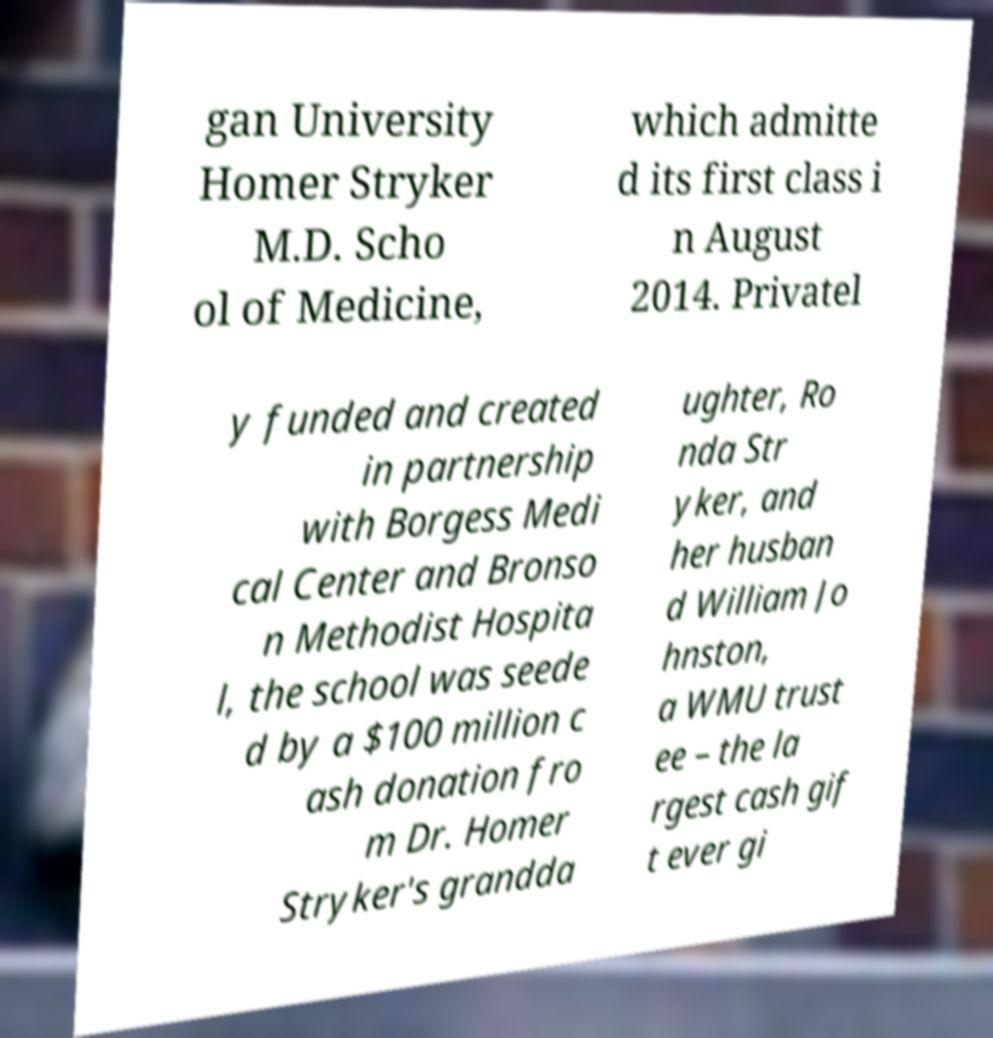Could you extract and type out the text from this image? gan University Homer Stryker M.D. Scho ol of Medicine, which admitte d its first class i n August 2014. Privatel y funded and created in partnership with Borgess Medi cal Center and Bronso n Methodist Hospita l, the school was seede d by a $100 million c ash donation fro m Dr. Homer Stryker's grandda ughter, Ro nda Str yker, and her husban d William Jo hnston, a WMU trust ee – the la rgest cash gif t ever gi 